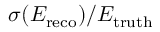<formula> <loc_0><loc_0><loc_500><loc_500>\sigma ( E _ { r e c o } ) / E _ { t r u t h }</formula> 